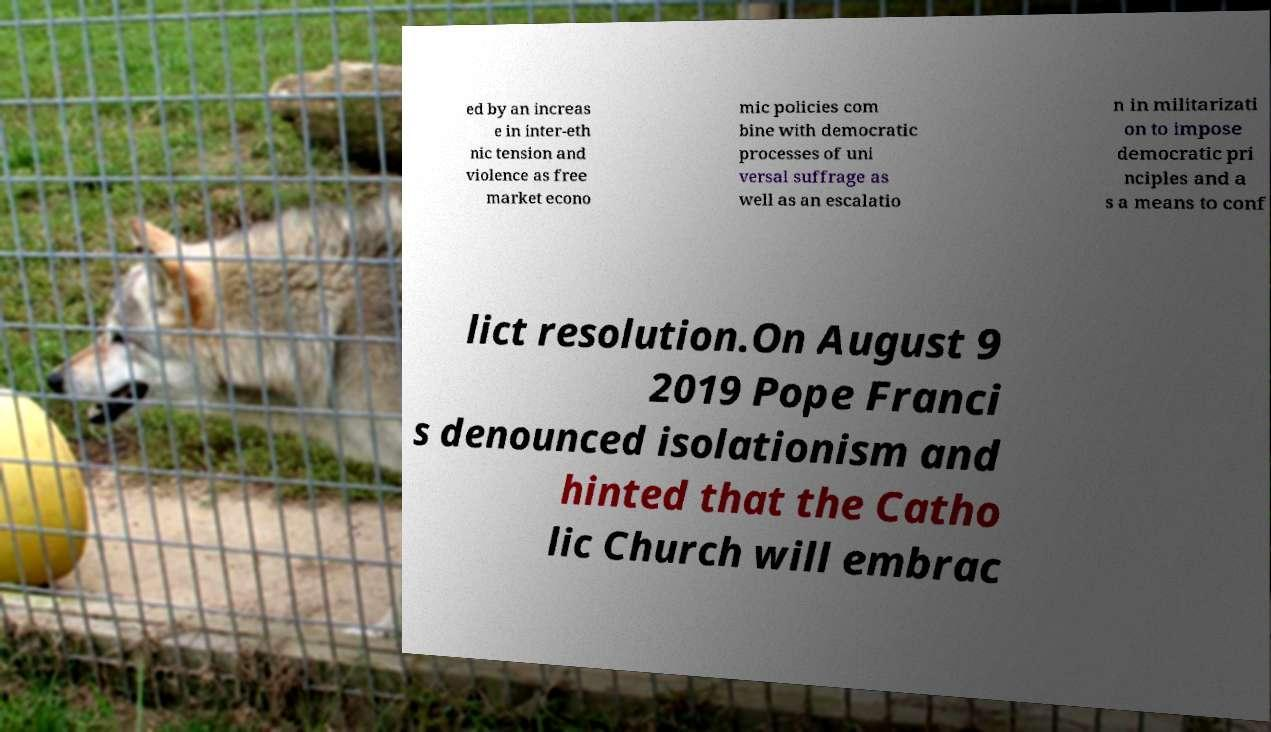Please read and relay the text visible in this image. What does it say? ed by an increas e in inter-eth nic tension and violence as free market econo mic policies com bine with democratic processes of uni versal suffrage as well as an escalatio n in militarizati on to impose democratic pri nciples and a s a means to conf lict resolution.On August 9 2019 Pope Franci s denounced isolationism and hinted that the Catho lic Church will embrac 